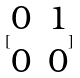<formula> <loc_0><loc_0><loc_500><loc_500>[ \begin{matrix} 0 & 1 \\ 0 & 0 \end{matrix} ]</formula> 